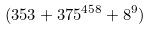Convert formula to latex. <formula><loc_0><loc_0><loc_500><loc_500>( 3 5 3 + 3 7 5 ^ { 4 5 8 } + 8 ^ { 9 } )</formula> 